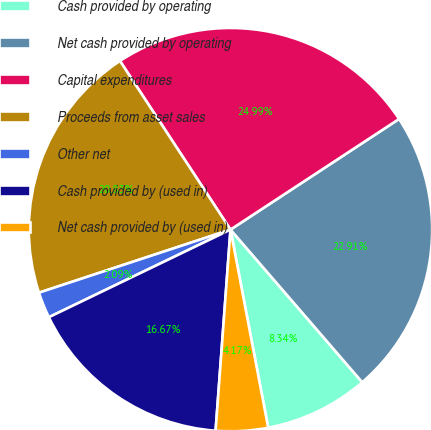Convert chart to OTSL. <chart><loc_0><loc_0><loc_500><loc_500><pie_chart><fcel>Cash provided by operating<fcel>Net cash provided by operating<fcel>Capital expenditures<fcel>Proceeds from asset sales<fcel>Other net<fcel>Cash provided by (used in)<fcel>Net cash provided by (used in)<nl><fcel>8.34%<fcel>22.91%<fcel>24.99%<fcel>20.83%<fcel>2.09%<fcel>16.67%<fcel>4.17%<nl></chart> 